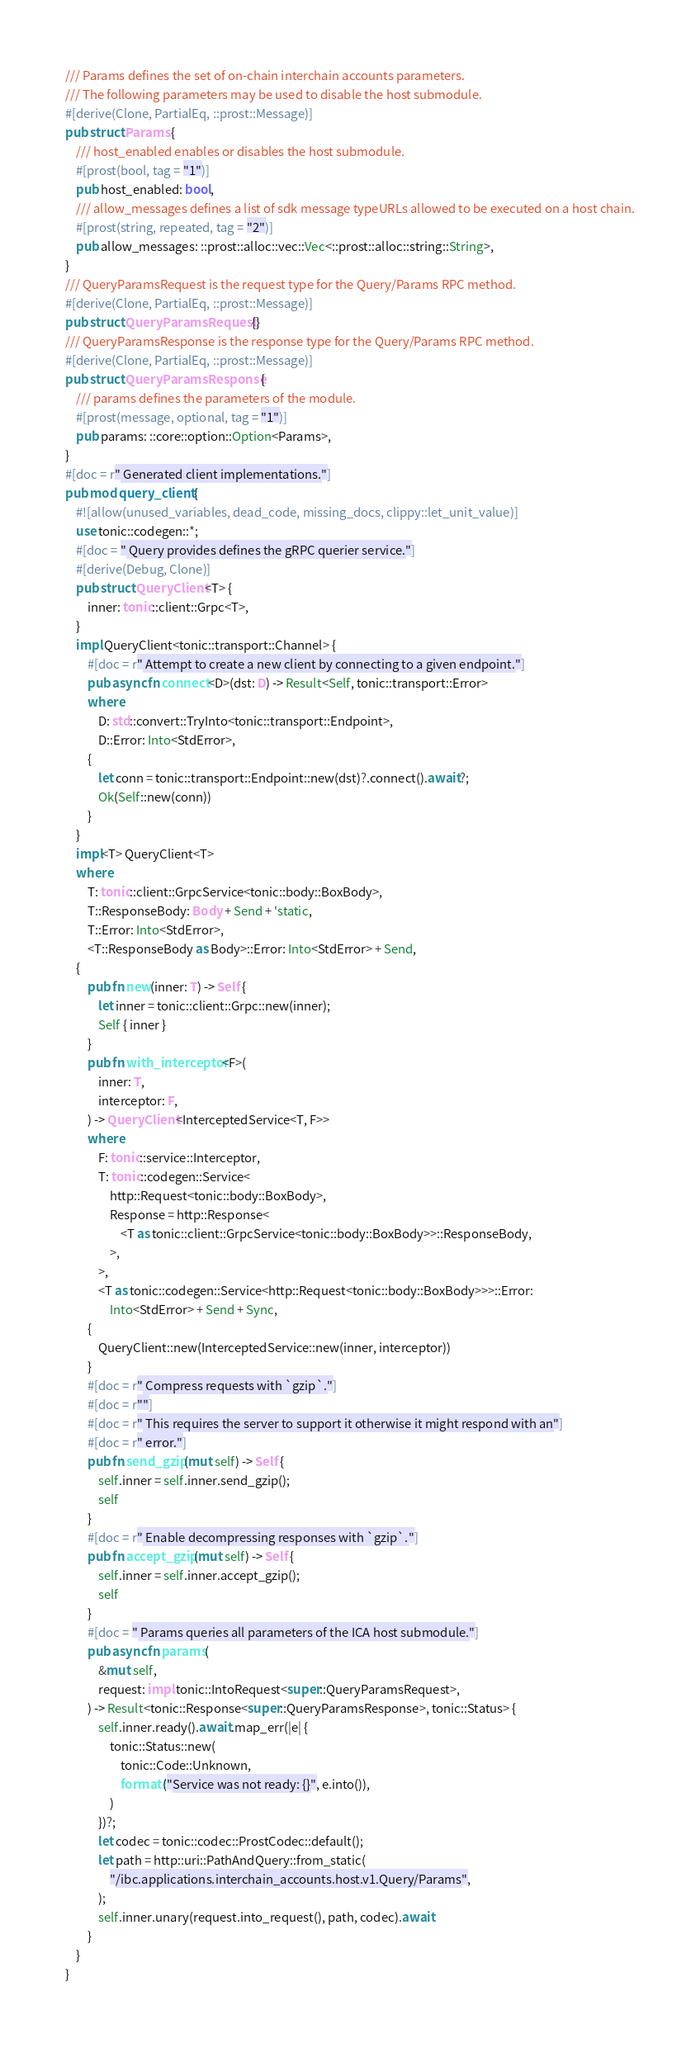<code> <loc_0><loc_0><loc_500><loc_500><_Rust_>/// Params defines the set of on-chain interchain accounts parameters.
/// The following parameters may be used to disable the host submodule.
#[derive(Clone, PartialEq, ::prost::Message)]
pub struct Params {
    /// host_enabled enables or disables the host submodule.
    #[prost(bool, tag = "1")]
    pub host_enabled: bool,
    /// allow_messages defines a list of sdk message typeURLs allowed to be executed on a host chain.
    #[prost(string, repeated, tag = "2")]
    pub allow_messages: ::prost::alloc::vec::Vec<::prost::alloc::string::String>,
}
/// QueryParamsRequest is the request type for the Query/Params RPC method.
#[derive(Clone, PartialEq, ::prost::Message)]
pub struct QueryParamsRequest {}
/// QueryParamsResponse is the response type for the Query/Params RPC method.
#[derive(Clone, PartialEq, ::prost::Message)]
pub struct QueryParamsResponse {
    /// params defines the parameters of the module.
    #[prost(message, optional, tag = "1")]
    pub params: ::core::option::Option<Params>,
}
#[doc = r" Generated client implementations."]
pub mod query_client {
    #![allow(unused_variables, dead_code, missing_docs, clippy::let_unit_value)]
    use tonic::codegen::*;
    #[doc = " Query provides defines the gRPC querier service."]
    #[derive(Debug, Clone)]
    pub struct QueryClient<T> {
        inner: tonic::client::Grpc<T>,
    }
    impl QueryClient<tonic::transport::Channel> {
        #[doc = r" Attempt to create a new client by connecting to a given endpoint."]
        pub async fn connect<D>(dst: D) -> Result<Self, tonic::transport::Error>
        where
            D: std::convert::TryInto<tonic::transport::Endpoint>,
            D::Error: Into<StdError>,
        {
            let conn = tonic::transport::Endpoint::new(dst)?.connect().await?;
            Ok(Self::new(conn))
        }
    }
    impl<T> QueryClient<T>
    where
        T: tonic::client::GrpcService<tonic::body::BoxBody>,
        T::ResponseBody: Body + Send + 'static,
        T::Error: Into<StdError>,
        <T::ResponseBody as Body>::Error: Into<StdError> + Send,
    {
        pub fn new(inner: T) -> Self {
            let inner = tonic::client::Grpc::new(inner);
            Self { inner }
        }
        pub fn with_interceptor<F>(
            inner: T,
            interceptor: F,
        ) -> QueryClient<InterceptedService<T, F>>
        where
            F: tonic::service::Interceptor,
            T: tonic::codegen::Service<
                http::Request<tonic::body::BoxBody>,
                Response = http::Response<
                    <T as tonic::client::GrpcService<tonic::body::BoxBody>>::ResponseBody,
                >,
            >,
            <T as tonic::codegen::Service<http::Request<tonic::body::BoxBody>>>::Error:
                Into<StdError> + Send + Sync,
        {
            QueryClient::new(InterceptedService::new(inner, interceptor))
        }
        #[doc = r" Compress requests with `gzip`."]
        #[doc = r""]
        #[doc = r" This requires the server to support it otherwise it might respond with an"]
        #[doc = r" error."]
        pub fn send_gzip(mut self) -> Self {
            self.inner = self.inner.send_gzip();
            self
        }
        #[doc = r" Enable decompressing responses with `gzip`."]
        pub fn accept_gzip(mut self) -> Self {
            self.inner = self.inner.accept_gzip();
            self
        }
        #[doc = " Params queries all parameters of the ICA host submodule."]
        pub async fn params(
            &mut self,
            request: impl tonic::IntoRequest<super::QueryParamsRequest>,
        ) -> Result<tonic::Response<super::QueryParamsResponse>, tonic::Status> {
            self.inner.ready().await.map_err(|e| {
                tonic::Status::new(
                    tonic::Code::Unknown,
                    format!("Service was not ready: {}", e.into()),
                )
            })?;
            let codec = tonic::codec::ProstCodec::default();
            let path = http::uri::PathAndQuery::from_static(
                "/ibc.applications.interchain_accounts.host.v1.Query/Params",
            );
            self.inner.unary(request.into_request(), path, codec).await
        }
    }
}
</code> 